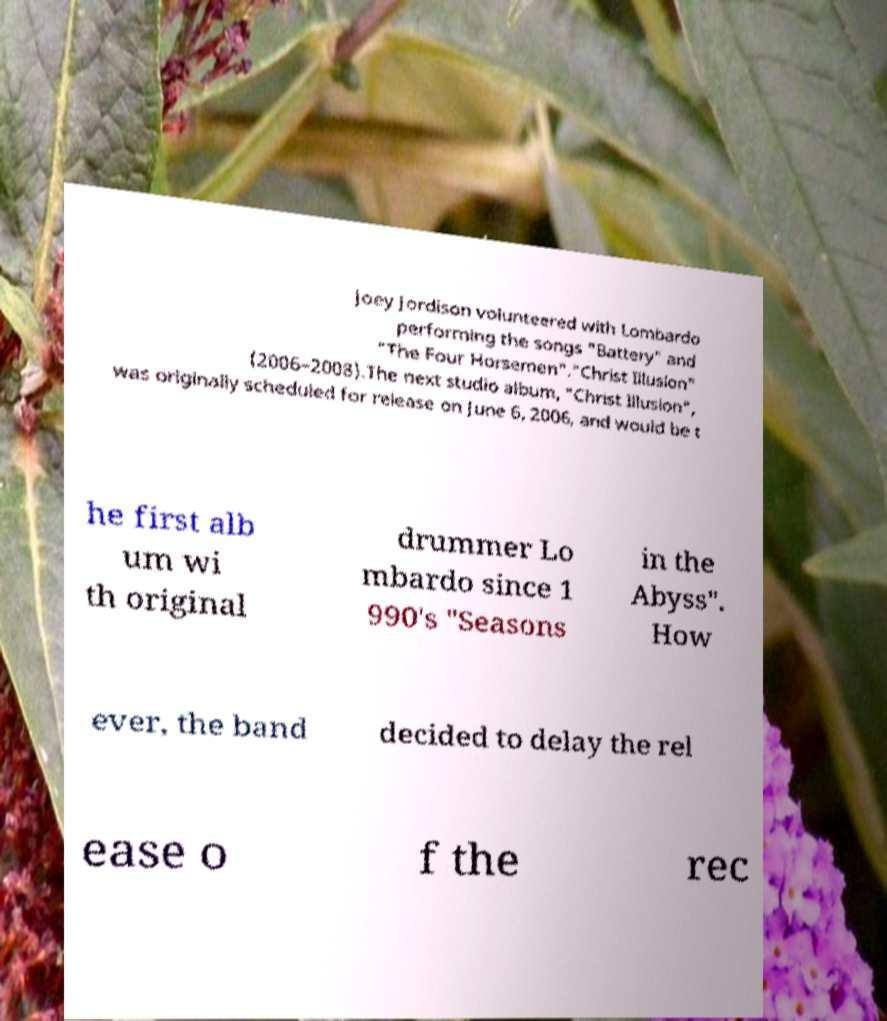For documentation purposes, I need the text within this image transcribed. Could you provide that? Joey Jordison volunteered with Lombardo performing the songs "Battery" and "The Four Horsemen"."Christ Illusion" (2006–2008).The next studio album, "Christ Illusion", was originally scheduled for release on June 6, 2006, and would be t he first alb um wi th original drummer Lo mbardo since 1 990's "Seasons in the Abyss". How ever, the band decided to delay the rel ease o f the rec 